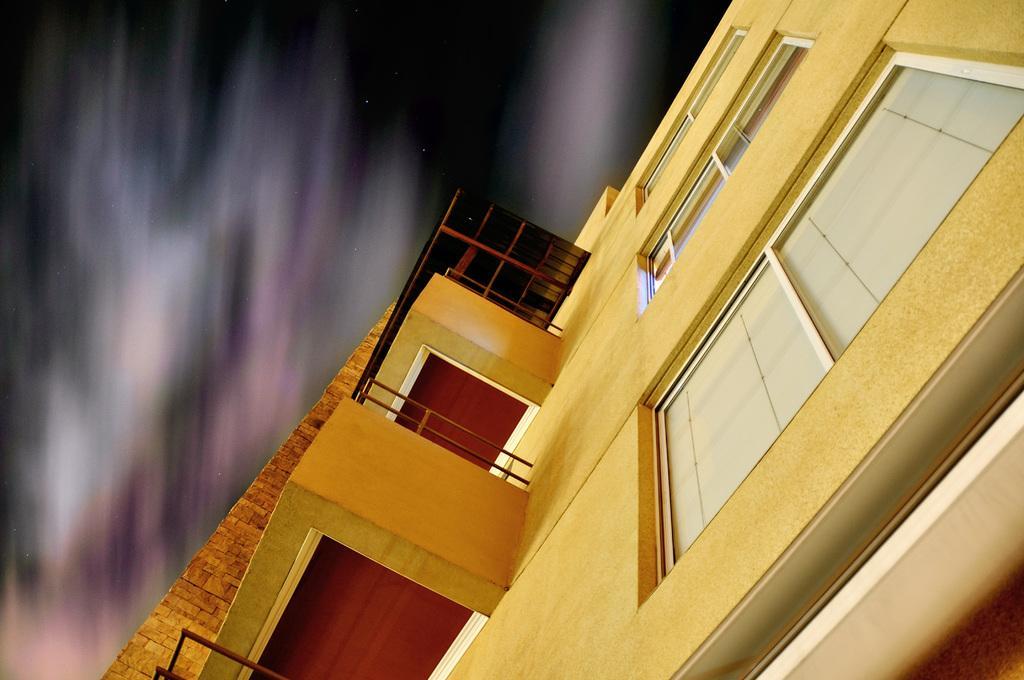Please provide a concise description of this image. On the right side, there is a building having glass windows. And the background is blurred. 